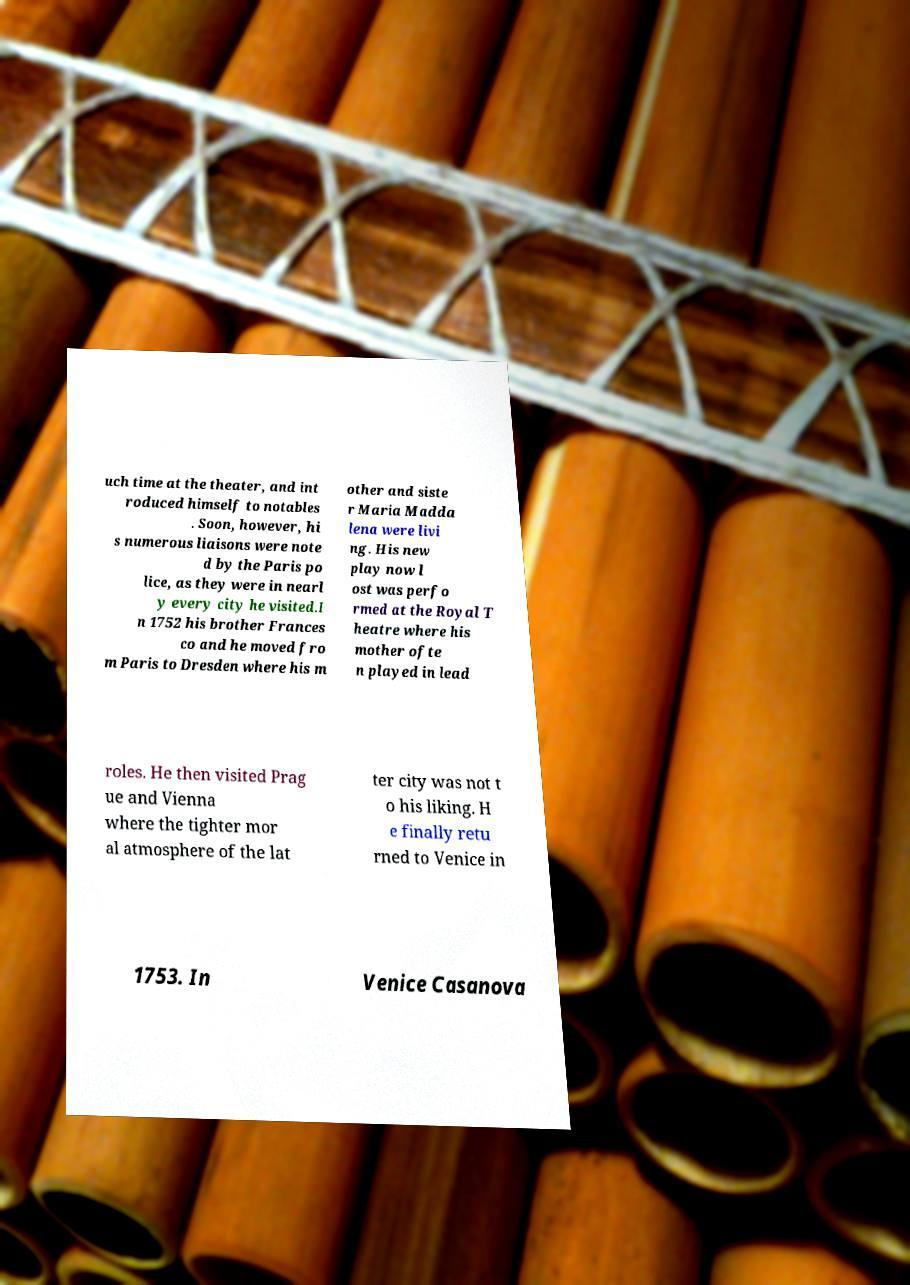Please read and relay the text visible in this image. What does it say? uch time at the theater, and int roduced himself to notables . Soon, however, hi s numerous liaisons were note d by the Paris po lice, as they were in nearl y every city he visited.I n 1752 his brother Frances co and he moved fro m Paris to Dresden where his m other and siste r Maria Madda lena were livi ng. His new play now l ost was perfo rmed at the Royal T heatre where his mother ofte n played in lead roles. He then visited Prag ue and Vienna where the tighter mor al atmosphere of the lat ter city was not t o his liking. H e finally retu rned to Venice in 1753. In Venice Casanova 